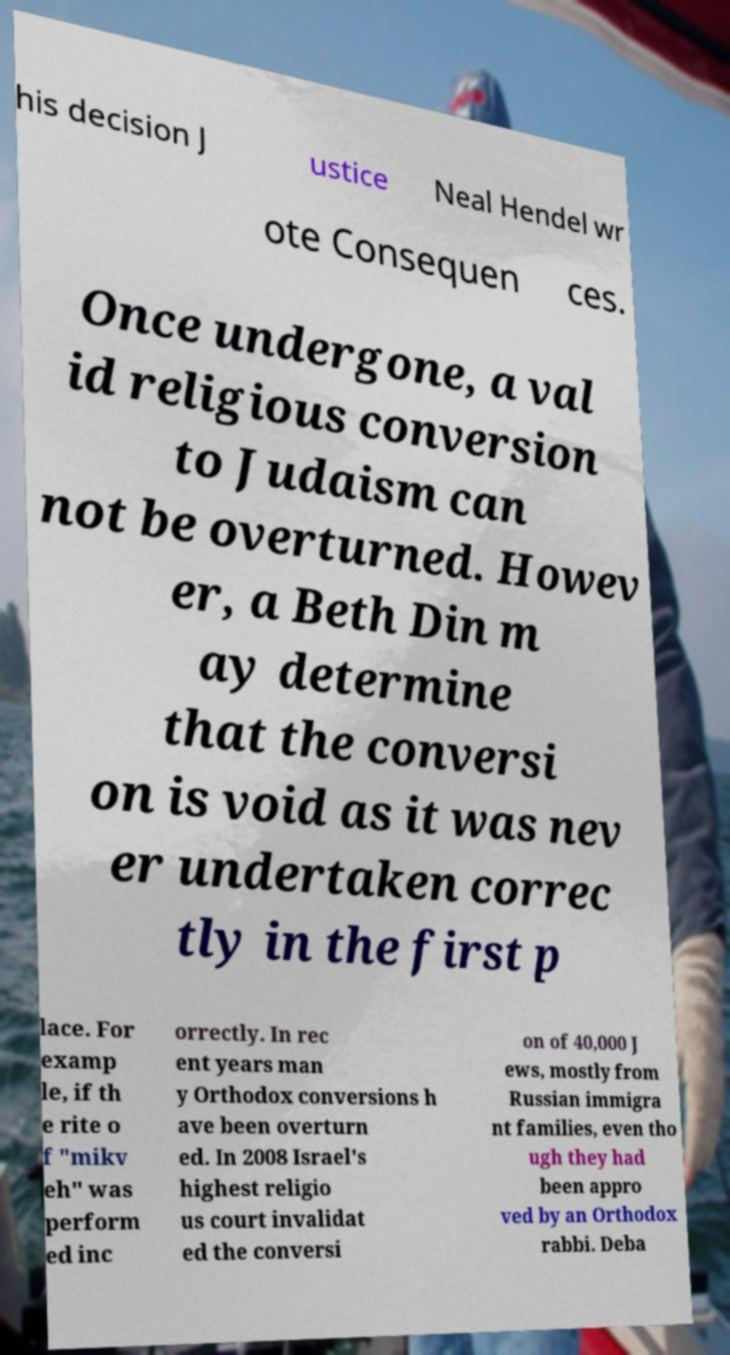Please read and relay the text visible in this image. What does it say? his decision J ustice Neal Hendel wr ote Consequen ces. Once undergone, a val id religious conversion to Judaism can not be overturned. Howev er, a Beth Din m ay determine that the conversi on is void as it was nev er undertaken correc tly in the first p lace. For examp le, if th e rite o f "mikv eh" was perform ed inc orrectly. In rec ent years man y Orthodox conversions h ave been overturn ed. In 2008 Israel's highest religio us court invalidat ed the conversi on of 40,000 J ews, mostly from Russian immigra nt families, even tho ugh they had been appro ved by an Orthodox rabbi. Deba 